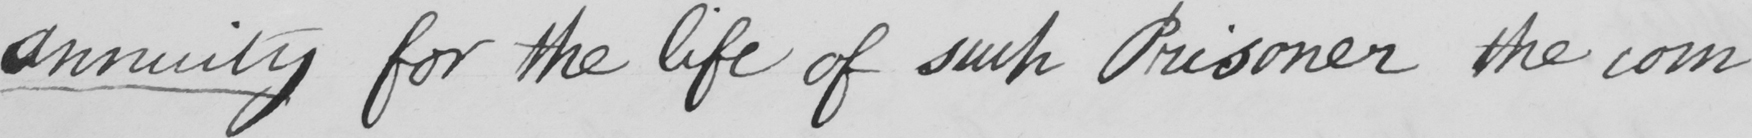Transcribe the text shown in this historical manuscript line. Annuity for the life of such Prisoner the com 